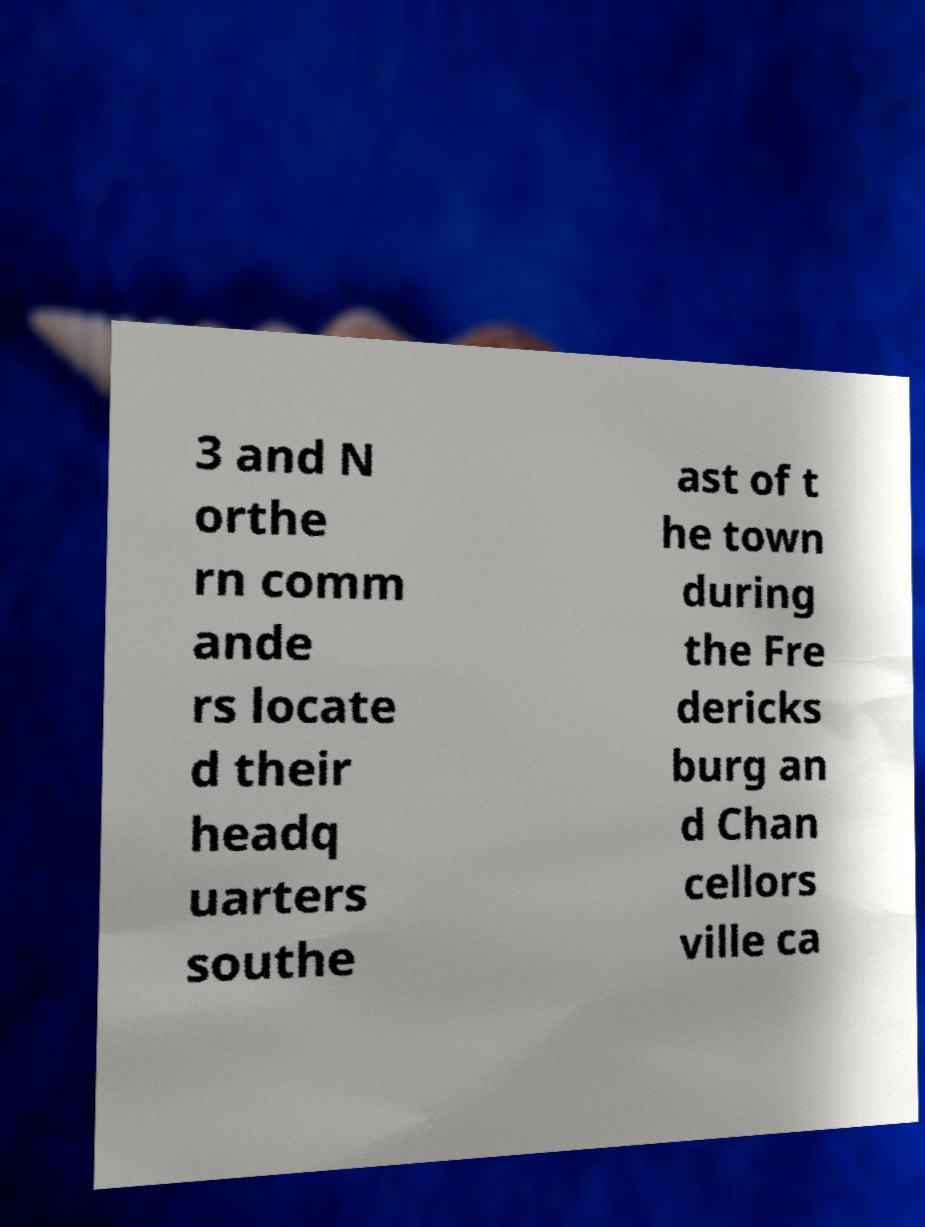Please identify and transcribe the text found in this image. 3 and N orthe rn comm ande rs locate d their headq uarters southe ast of t he town during the Fre dericks burg an d Chan cellors ville ca 